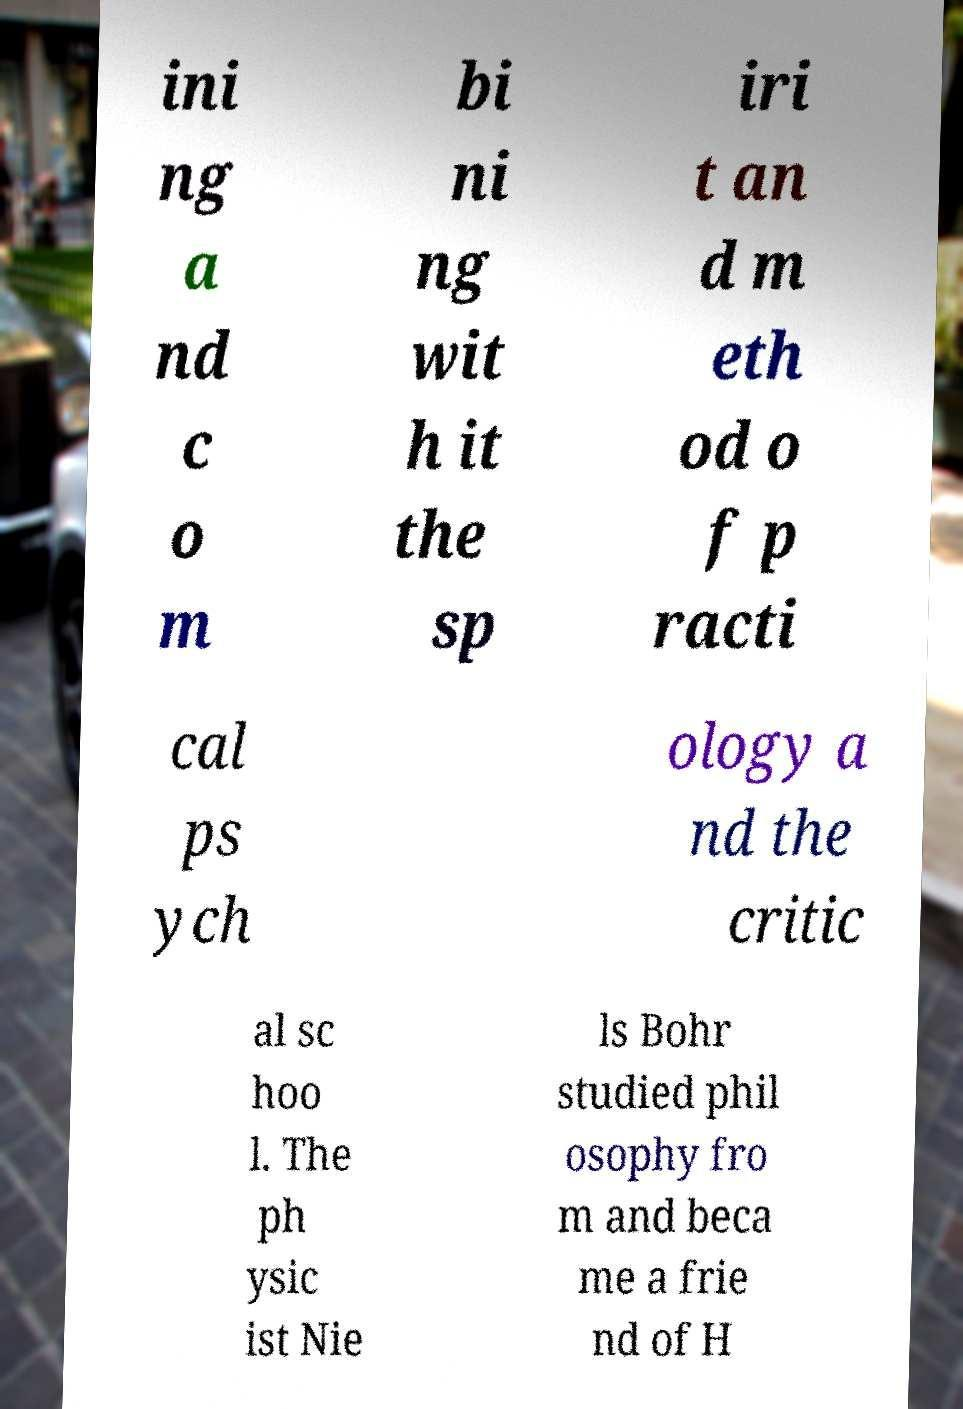What messages or text are displayed in this image? I need them in a readable, typed format. ini ng a nd c o m bi ni ng wit h it the sp iri t an d m eth od o f p racti cal ps ych ology a nd the critic al sc hoo l. The ph ysic ist Nie ls Bohr studied phil osophy fro m and beca me a frie nd of H 